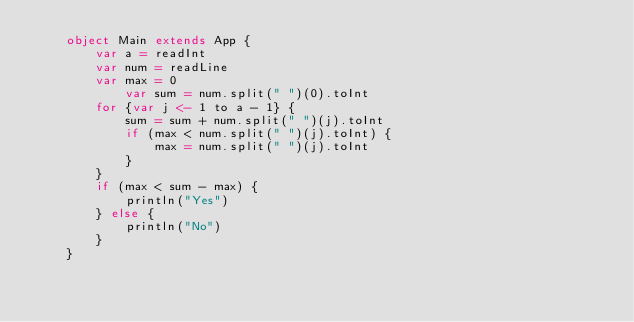<code> <loc_0><loc_0><loc_500><loc_500><_Scala_>    object Main extends App {
        var a = readInt
        var num = readLine
        var max = 0
            var sum = num.split(" ")(0).toInt
        for {var j <- 1 to a - 1} {
            sum = sum + num.split(" ")(j).toInt
            if (max < num.split(" ")(j).toInt) {
                max = num.split(" ")(j).toInt
            }
        }
        if (max < sum - max) {
            println("Yes")
        } else {
            println("No")
        }
    }</code> 